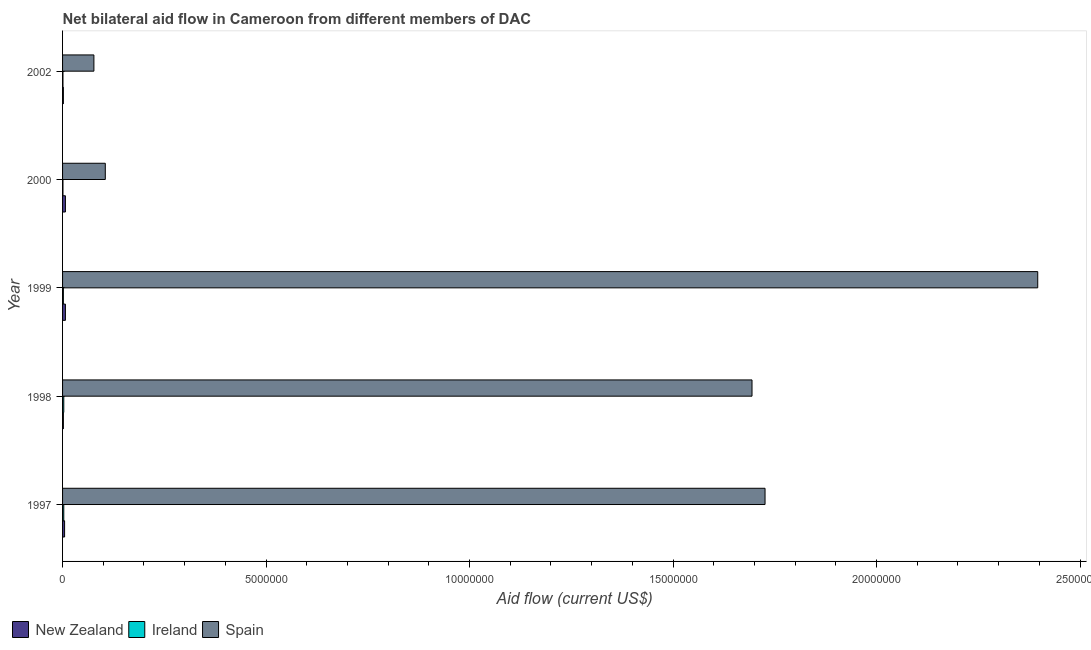How many groups of bars are there?
Ensure brevity in your answer.  5. How many bars are there on the 3rd tick from the top?
Your response must be concise. 3. What is the label of the 1st group of bars from the top?
Keep it short and to the point. 2002. In how many cases, is the number of bars for a given year not equal to the number of legend labels?
Make the answer very short. 0. What is the amount of aid provided by ireland in 2000?
Provide a short and direct response. 10000. Across all years, what is the maximum amount of aid provided by new zealand?
Your response must be concise. 7.00e+04. Across all years, what is the minimum amount of aid provided by new zealand?
Offer a very short reply. 2.00e+04. In which year was the amount of aid provided by ireland maximum?
Your answer should be compact. 1997. In which year was the amount of aid provided by ireland minimum?
Your response must be concise. 2000. What is the total amount of aid provided by spain in the graph?
Keep it short and to the point. 6.00e+07. What is the difference between the amount of aid provided by new zealand in 1998 and that in 2000?
Offer a terse response. -5.00e+04. What is the difference between the amount of aid provided by new zealand in 2000 and the amount of aid provided by spain in 1998?
Offer a terse response. -1.69e+07. What is the average amount of aid provided by new zealand per year?
Make the answer very short. 4.60e+04. In the year 1999, what is the difference between the amount of aid provided by ireland and amount of aid provided by new zealand?
Provide a succinct answer. -5.00e+04. In how many years, is the amount of aid provided by new zealand greater than 3000000 US$?
Ensure brevity in your answer.  0. What is the ratio of the amount of aid provided by spain in 1999 to that in 2000?
Your answer should be compact. 22.82. Is the amount of aid provided by ireland in 1998 less than that in 1999?
Provide a succinct answer. No. Is the difference between the amount of aid provided by ireland in 1998 and 1999 greater than the difference between the amount of aid provided by spain in 1998 and 1999?
Your answer should be very brief. Yes. What is the difference between the highest and the second highest amount of aid provided by spain?
Keep it short and to the point. 6.70e+06. What is the difference between the highest and the lowest amount of aid provided by new zealand?
Your answer should be compact. 5.00e+04. Is the sum of the amount of aid provided by ireland in 1997 and 2002 greater than the maximum amount of aid provided by spain across all years?
Your answer should be very brief. No. What does the 1st bar from the top in 2002 represents?
Give a very brief answer. Spain. What does the 2nd bar from the bottom in 2002 represents?
Provide a succinct answer. Ireland. How many bars are there?
Keep it short and to the point. 15. Are all the bars in the graph horizontal?
Keep it short and to the point. Yes. What is the difference between two consecutive major ticks on the X-axis?
Your answer should be compact. 5.00e+06. Does the graph contain any zero values?
Ensure brevity in your answer.  No. Does the graph contain grids?
Your response must be concise. No. How are the legend labels stacked?
Your answer should be compact. Horizontal. What is the title of the graph?
Provide a short and direct response. Net bilateral aid flow in Cameroon from different members of DAC. Does "ICT services" appear as one of the legend labels in the graph?
Your answer should be compact. No. What is the Aid flow (current US$) in New Zealand in 1997?
Keep it short and to the point. 5.00e+04. What is the Aid flow (current US$) of Spain in 1997?
Keep it short and to the point. 1.73e+07. What is the Aid flow (current US$) of New Zealand in 1998?
Make the answer very short. 2.00e+04. What is the Aid flow (current US$) in Spain in 1998?
Ensure brevity in your answer.  1.69e+07. What is the Aid flow (current US$) of Spain in 1999?
Provide a short and direct response. 2.40e+07. What is the Aid flow (current US$) in Ireland in 2000?
Provide a short and direct response. 10000. What is the Aid flow (current US$) of Spain in 2000?
Give a very brief answer. 1.05e+06. What is the Aid flow (current US$) in Ireland in 2002?
Provide a succinct answer. 10000. What is the Aid flow (current US$) of Spain in 2002?
Offer a terse response. 7.70e+05. Across all years, what is the maximum Aid flow (current US$) of Spain?
Make the answer very short. 2.40e+07. Across all years, what is the minimum Aid flow (current US$) of Spain?
Your answer should be compact. 7.70e+05. What is the total Aid flow (current US$) in New Zealand in the graph?
Provide a succinct answer. 2.30e+05. What is the total Aid flow (current US$) in Spain in the graph?
Keep it short and to the point. 6.00e+07. What is the difference between the Aid flow (current US$) of New Zealand in 1997 and that in 1999?
Make the answer very short. -2.00e+04. What is the difference between the Aid flow (current US$) in Ireland in 1997 and that in 1999?
Your answer should be compact. 10000. What is the difference between the Aid flow (current US$) in Spain in 1997 and that in 1999?
Ensure brevity in your answer.  -6.70e+06. What is the difference between the Aid flow (current US$) in New Zealand in 1997 and that in 2000?
Make the answer very short. -2.00e+04. What is the difference between the Aid flow (current US$) of Spain in 1997 and that in 2000?
Offer a very short reply. 1.62e+07. What is the difference between the Aid flow (current US$) of New Zealand in 1997 and that in 2002?
Keep it short and to the point. 3.00e+04. What is the difference between the Aid flow (current US$) of Ireland in 1997 and that in 2002?
Keep it short and to the point. 2.00e+04. What is the difference between the Aid flow (current US$) in Spain in 1997 and that in 2002?
Your answer should be compact. 1.65e+07. What is the difference between the Aid flow (current US$) of New Zealand in 1998 and that in 1999?
Your response must be concise. -5.00e+04. What is the difference between the Aid flow (current US$) in Spain in 1998 and that in 1999?
Provide a short and direct response. -7.02e+06. What is the difference between the Aid flow (current US$) of Ireland in 1998 and that in 2000?
Provide a succinct answer. 2.00e+04. What is the difference between the Aid flow (current US$) of Spain in 1998 and that in 2000?
Your response must be concise. 1.59e+07. What is the difference between the Aid flow (current US$) of New Zealand in 1998 and that in 2002?
Your response must be concise. 0. What is the difference between the Aid flow (current US$) in Spain in 1998 and that in 2002?
Give a very brief answer. 1.62e+07. What is the difference between the Aid flow (current US$) in Spain in 1999 and that in 2000?
Provide a succinct answer. 2.29e+07. What is the difference between the Aid flow (current US$) in Spain in 1999 and that in 2002?
Keep it short and to the point. 2.32e+07. What is the difference between the Aid flow (current US$) of New Zealand in 2000 and that in 2002?
Provide a succinct answer. 5.00e+04. What is the difference between the Aid flow (current US$) of Spain in 2000 and that in 2002?
Provide a short and direct response. 2.80e+05. What is the difference between the Aid flow (current US$) of New Zealand in 1997 and the Aid flow (current US$) of Spain in 1998?
Your answer should be compact. -1.69e+07. What is the difference between the Aid flow (current US$) of Ireland in 1997 and the Aid flow (current US$) of Spain in 1998?
Give a very brief answer. -1.69e+07. What is the difference between the Aid flow (current US$) of New Zealand in 1997 and the Aid flow (current US$) of Ireland in 1999?
Provide a succinct answer. 3.00e+04. What is the difference between the Aid flow (current US$) of New Zealand in 1997 and the Aid flow (current US$) of Spain in 1999?
Your answer should be compact. -2.39e+07. What is the difference between the Aid flow (current US$) in Ireland in 1997 and the Aid flow (current US$) in Spain in 1999?
Offer a terse response. -2.39e+07. What is the difference between the Aid flow (current US$) of New Zealand in 1997 and the Aid flow (current US$) of Spain in 2000?
Provide a succinct answer. -1.00e+06. What is the difference between the Aid flow (current US$) in Ireland in 1997 and the Aid flow (current US$) in Spain in 2000?
Offer a very short reply. -1.02e+06. What is the difference between the Aid flow (current US$) in New Zealand in 1997 and the Aid flow (current US$) in Ireland in 2002?
Provide a short and direct response. 4.00e+04. What is the difference between the Aid flow (current US$) in New Zealand in 1997 and the Aid flow (current US$) in Spain in 2002?
Your answer should be very brief. -7.20e+05. What is the difference between the Aid flow (current US$) in Ireland in 1997 and the Aid flow (current US$) in Spain in 2002?
Offer a terse response. -7.40e+05. What is the difference between the Aid flow (current US$) in New Zealand in 1998 and the Aid flow (current US$) in Spain in 1999?
Keep it short and to the point. -2.39e+07. What is the difference between the Aid flow (current US$) in Ireland in 1998 and the Aid flow (current US$) in Spain in 1999?
Offer a terse response. -2.39e+07. What is the difference between the Aid flow (current US$) of New Zealand in 1998 and the Aid flow (current US$) of Ireland in 2000?
Offer a very short reply. 10000. What is the difference between the Aid flow (current US$) of New Zealand in 1998 and the Aid flow (current US$) of Spain in 2000?
Offer a terse response. -1.03e+06. What is the difference between the Aid flow (current US$) of Ireland in 1998 and the Aid flow (current US$) of Spain in 2000?
Offer a very short reply. -1.02e+06. What is the difference between the Aid flow (current US$) of New Zealand in 1998 and the Aid flow (current US$) of Spain in 2002?
Offer a very short reply. -7.50e+05. What is the difference between the Aid flow (current US$) of Ireland in 1998 and the Aid flow (current US$) of Spain in 2002?
Provide a short and direct response. -7.40e+05. What is the difference between the Aid flow (current US$) of New Zealand in 1999 and the Aid flow (current US$) of Spain in 2000?
Your answer should be compact. -9.80e+05. What is the difference between the Aid flow (current US$) in Ireland in 1999 and the Aid flow (current US$) in Spain in 2000?
Your response must be concise. -1.03e+06. What is the difference between the Aid flow (current US$) of New Zealand in 1999 and the Aid flow (current US$) of Ireland in 2002?
Your answer should be compact. 6.00e+04. What is the difference between the Aid flow (current US$) of New Zealand in 1999 and the Aid flow (current US$) of Spain in 2002?
Keep it short and to the point. -7.00e+05. What is the difference between the Aid flow (current US$) of Ireland in 1999 and the Aid flow (current US$) of Spain in 2002?
Provide a short and direct response. -7.50e+05. What is the difference between the Aid flow (current US$) in New Zealand in 2000 and the Aid flow (current US$) in Spain in 2002?
Your response must be concise. -7.00e+05. What is the difference between the Aid flow (current US$) in Ireland in 2000 and the Aid flow (current US$) in Spain in 2002?
Your answer should be compact. -7.60e+05. What is the average Aid flow (current US$) in New Zealand per year?
Provide a short and direct response. 4.60e+04. What is the average Aid flow (current US$) in Ireland per year?
Offer a terse response. 2.00e+04. What is the average Aid flow (current US$) of Spain per year?
Provide a short and direct response. 1.20e+07. In the year 1997, what is the difference between the Aid flow (current US$) in New Zealand and Aid flow (current US$) in Ireland?
Offer a very short reply. 2.00e+04. In the year 1997, what is the difference between the Aid flow (current US$) of New Zealand and Aid flow (current US$) of Spain?
Your answer should be compact. -1.72e+07. In the year 1997, what is the difference between the Aid flow (current US$) of Ireland and Aid flow (current US$) of Spain?
Make the answer very short. -1.72e+07. In the year 1998, what is the difference between the Aid flow (current US$) of New Zealand and Aid flow (current US$) of Spain?
Provide a succinct answer. -1.69e+07. In the year 1998, what is the difference between the Aid flow (current US$) in Ireland and Aid flow (current US$) in Spain?
Your answer should be compact. -1.69e+07. In the year 1999, what is the difference between the Aid flow (current US$) of New Zealand and Aid flow (current US$) of Ireland?
Ensure brevity in your answer.  5.00e+04. In the year 1999, what is the difference between the Aid flow (current US$) in New Zealand and Aid flow (current US$) in Spain?
Offer a terse response. -2.39e+07. In the year 1999, what is the difference between the Aid flow (current US$) in Ireland and Aid flow (current US$) in Spain?
Make the answer very short. -2.39e+07. In the year 2000, what is the difference between the Aid flow (current US$) of New Zealand and Aid flow (current US$) of Spain?
Make the answer very short. -9.80e+05. In the year 2000, what is the difference between the Aid flow (current US$) of Ireland and Aid flow (current US$) of Spain?
Make the answer very short. -1.04e+06. In the year 2002, what is the difference between the Aid flow (current US$) of New Zealand and Aid flow (current US$) of Spain?
Keep it short and to the point. -7.50e+05. In the year 2002, what is the difference between the Aid flow (current US$) in Ireland and Aid flow (current US$) in Spain?
Offer a terse response. -7.60e+05. What is the ratio of the Aid flow (current US$) in New Zealand in 1997 to that in 1998?
Keep it short and to the point. 2.5. What is the ratio of the Aid flow (current US$) of Ireland in 1997 to that in 1998?
Provide a short and direct response. 1. What is the ratio of the Aid flow (current US$) of Spain in 1997 to that in 1998?
Provide a succinct answer. 1.02. What is the ratio of the Aid flow (current US$) of New Zealand in 1997 to that in 1999?
Your answer should be compact. 0.71. What is the ratio of the Aid flow (current US$) of Spain in 1997 to that in 1999?
Your response must be concise. 0.72. What is the ratio of the Aid flow (current US$) in New Zealand in 1997 to that in 2000?
Ensure brevity in your answer.  0.71. What is the ratio of the Aid flow (current US$) in Spain in 1997 to that in 2000?
Provide a short and direct response. 16.44. What is the ratio of the Aid flow (current US$) of Ireland in 1997 to that in 2002?
Provide a short and direct response. 3. What is the ratio of the Aid flow (current US$) of Spain in 1997 to that in 2002?
Make the answer very short. 22.42. What is the ratio of the Aid flow (current US$) in New Zealand in 1998 to that in 1999?
Keep it short and to the point. 0.29. What is the ratio of the Aid flow (current US$) of Ireland in 1998 to that in 1999?
Ensure brevity in your answer.  1.5. What is the ratio of the Aid flow (current US$) in Spain in 1998 to that in 1999?
Your answer should be compact. 0.71. What is the ratio of the Aid flow (current US$) in New Zealand in 1998 to that in 2000?
Offer a terse response. 0.29. What is the ratio of the Aid flow (current US$) of Spain in 1998 to that in 2000?
Make the answer very short. 16.13. What is the ratio of the Aid flow (current US$) in New Zealand in 1998 to that in 2002?
Your answer should be very brief. 1. What is the ratio of the Aid flow (current US$) of Spain in 1998 to that in 2002?
Make the answer very short. 22. What is the ratio of the Aid flow (current US$) of New Zealand in 1999 to that in 2000?
Ensure brevity in your answer.  1. What is the ratio of the Aid flow (current US$) of Spain in 1999 to that in 2000?
Provide a short and direct response. 22.82. What is the ratio of the Aid flow (current US$) of Spain in 1999 to that in 2002?
Your answer should be very brief. 31.12. What is the ratio of the Aid flow (current US$) of Spain in 2000 to that in 2002?
Keep it short and to the point. 1.36. What is the difference between the highest and the second highest Aid flow (current US$) of Ireland?
Offer a terse response. 0. What is the difference between the highest and the second highest Aid flow (current US$) in Spain?
Your response must be concise. 6.70e+06. What is the difference between the highest and the lowest Aid flow (current US$) of Spain?
Keep it short and to the point. 2.32e+07. 